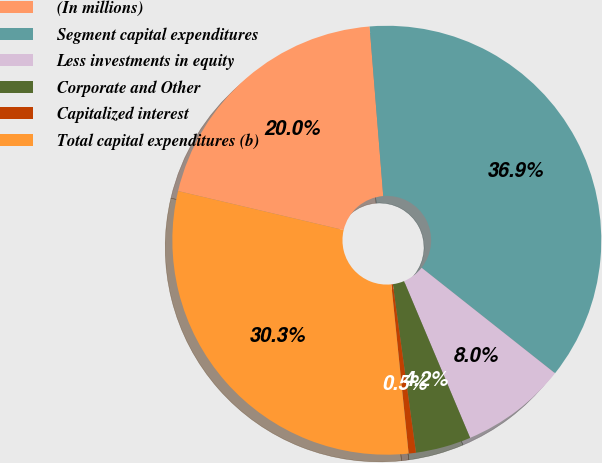<chart> <loc_0><loc_0><loc_500><loc_500><pie_chart><fcel>(In millions)<fcel>Segment capital expenditures<fcel>Less investments in equity<fcel>Corporate and Other<fcel>Capitalized interest<fcel>Total capital expenditures (b)<nl><fcel>20.04%<fcel>36.93%<fcel>8.0%<fcel>4.18%<fcel>0.55%<fcel>30.31%<nl></chart> 